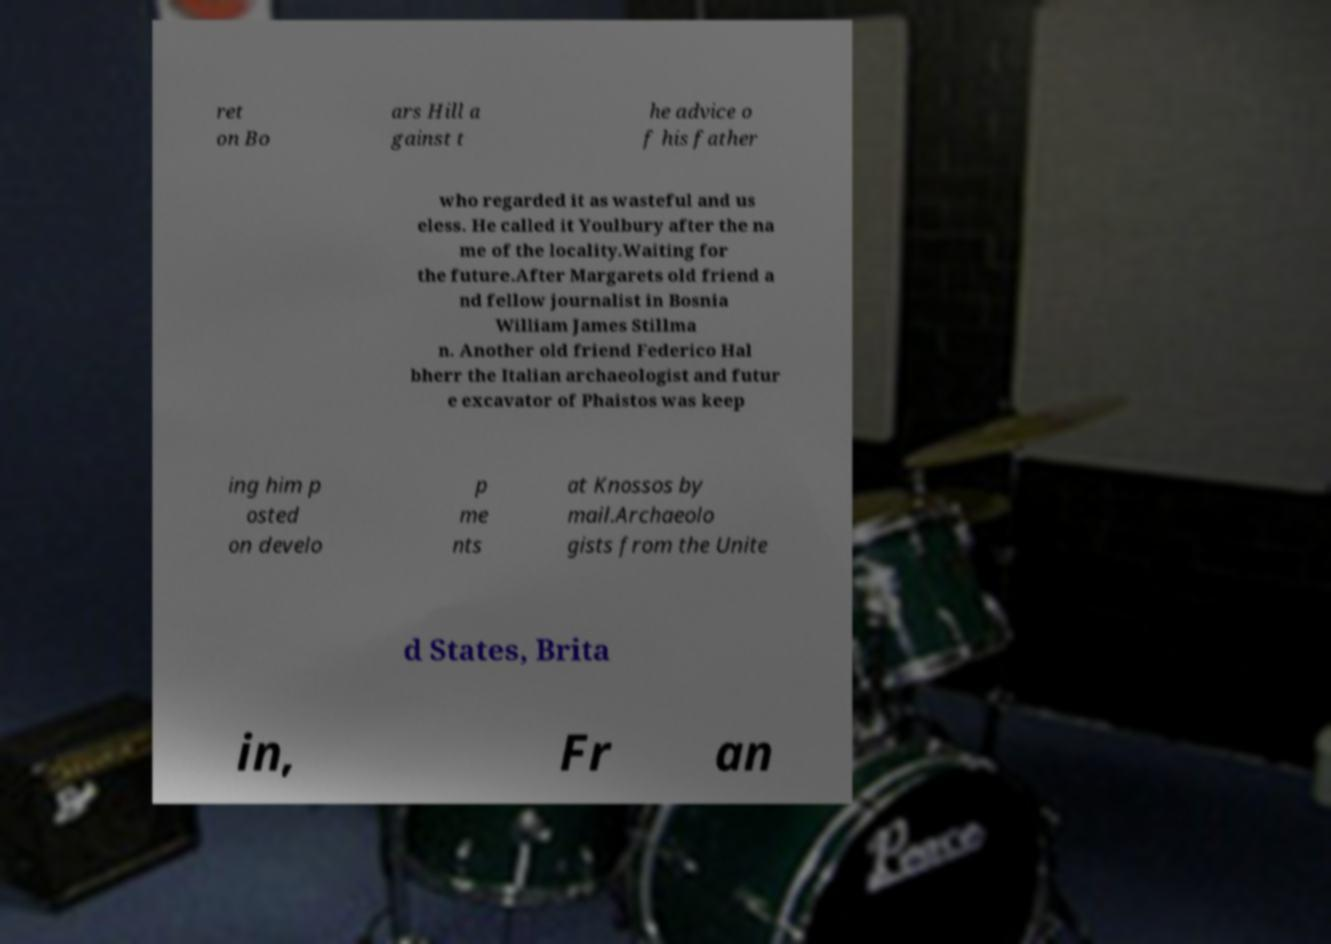Can you read and provide the text displayed in the image?This photo seems to have some interesting text. Can you extract and type it out for me? ret on Bo ars Hill a gainst t he advice o f his father who regarded it as wasteful and us eless. He called it Youlbury after the na me of the locality.Waiting for the future.After Margarets old friend a nd fellow journalist in Bosnia William James Stillma n. Another old friend Federico Hal bherr the Italian archaeologist and futur e excavator of Phaistos was keep ing him p osted on develo p me nts at Knossos by mail.Archaeolo gists from the Unite d States, Brita in, Fr an 